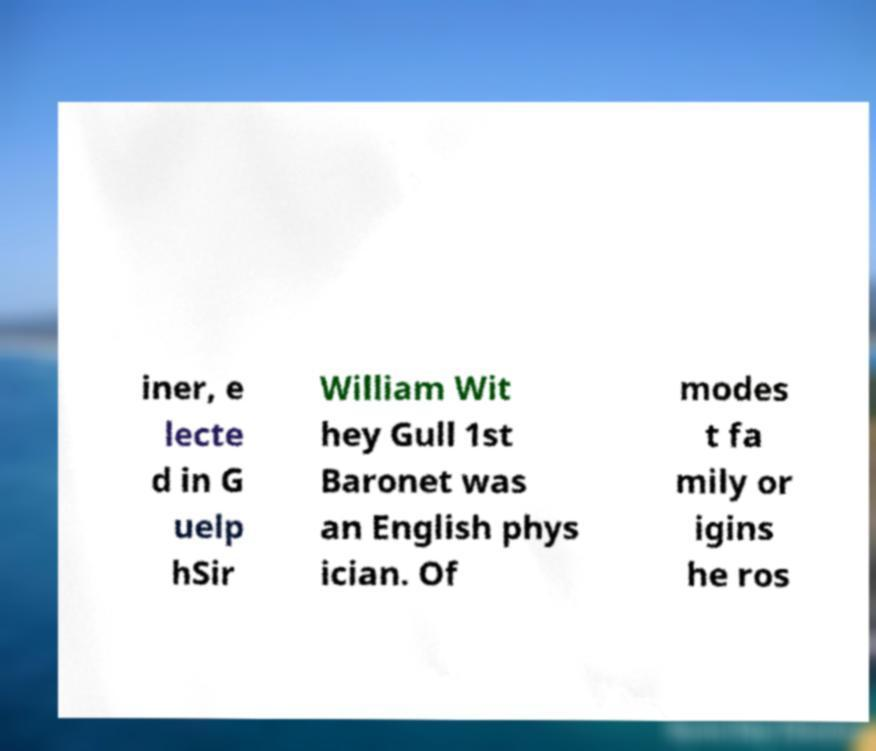For documentation purposes, I need the text within this image transcribed. Could you provide that? iner, e lecte d in G uelp hSir William Wit hey Gull 1st Baronet was an English phys ician. Of modes t fa mily or igins he ros 